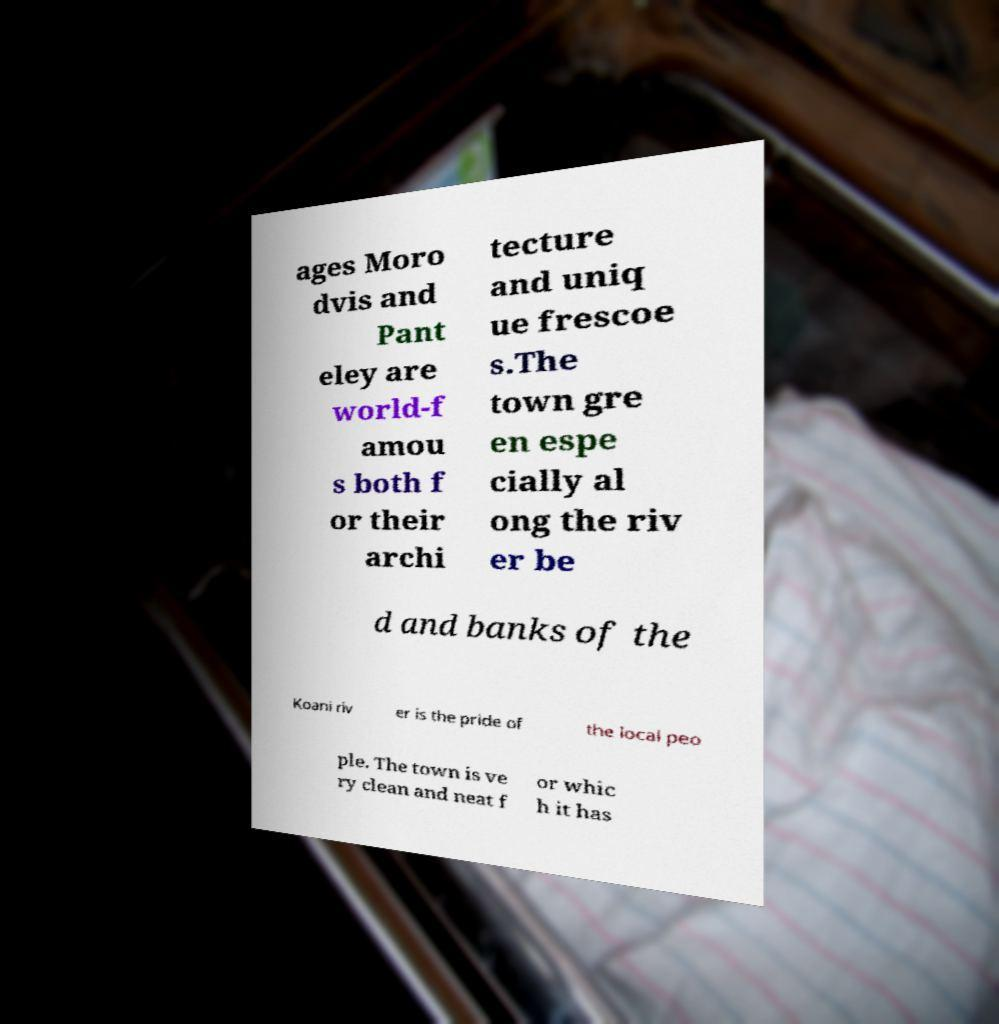Could you assist in decoding the text presented in this image and type it out clearly? ages Moro dvis and Pant eley are world-f amou s both f or their archi tecture and uniq ue frescoe s.The town gre en espe cially al ong the riv er be d and banks of the Koani riv er is the pride of the local peo ple. The town is ve ry clean and neat f or whic h it has 